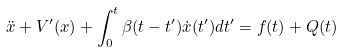Convert formula to latex. <formula><loc_0><loc_0><loc_500><loc_500>\ddot { x } + V ^ { \prime } ( x ) + \int _ { 0 } ^ { t } \beta ( t - t ^ { \prime } ) \dot { x } ( t ^ { \prime } ) d t ^ { \prime } = f ( t ) + Q ( t )</formula> 